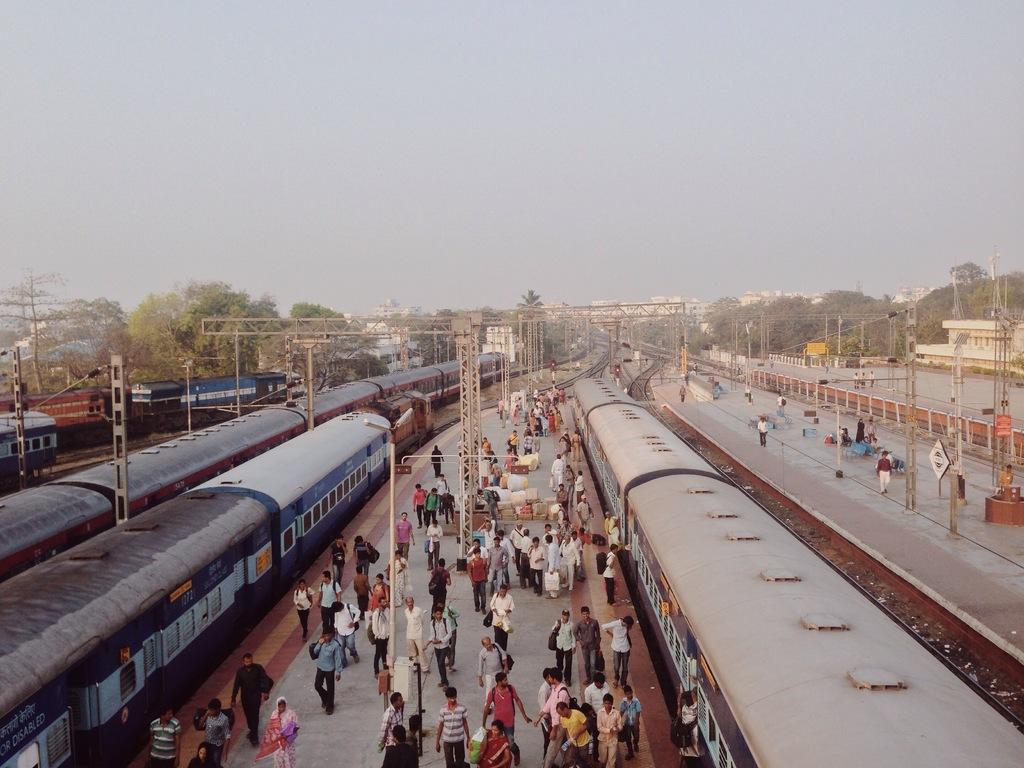Please provide a concise description of this image. Here I can see a railway station. There are some trains on the railway tracks. I can see many people are walking on the platforms and there are some poles. In the background, I can see the buildings and trees. On the top of the image I can see the sky. 